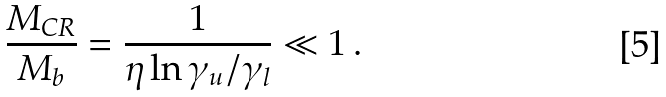Convert formula to latex. <formula><loc_0><loc_0><loc_500><loc_500>\frac { M _ { C R } } { M _ { b } } = \frac { 1 } { \eta \ln \gamma _ { u } / \gamma _ { l } } \ll 1 \, .</formula> 